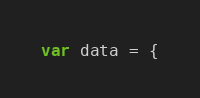<code> <loc_0><loc_0><loc_500><loc_500><_JavaScript_>var data = {</code> 